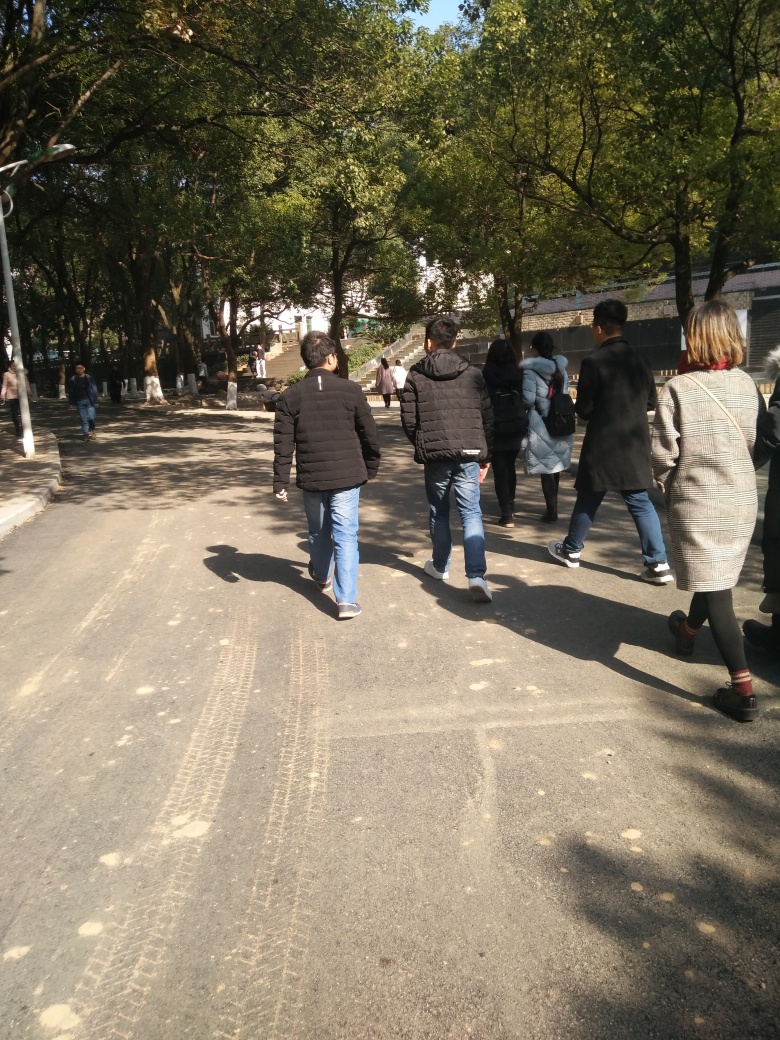What time of day could this picture have been taken? Given the shadows cast on the ground and the quality of the light, it seems to be mid to late afternoon. 